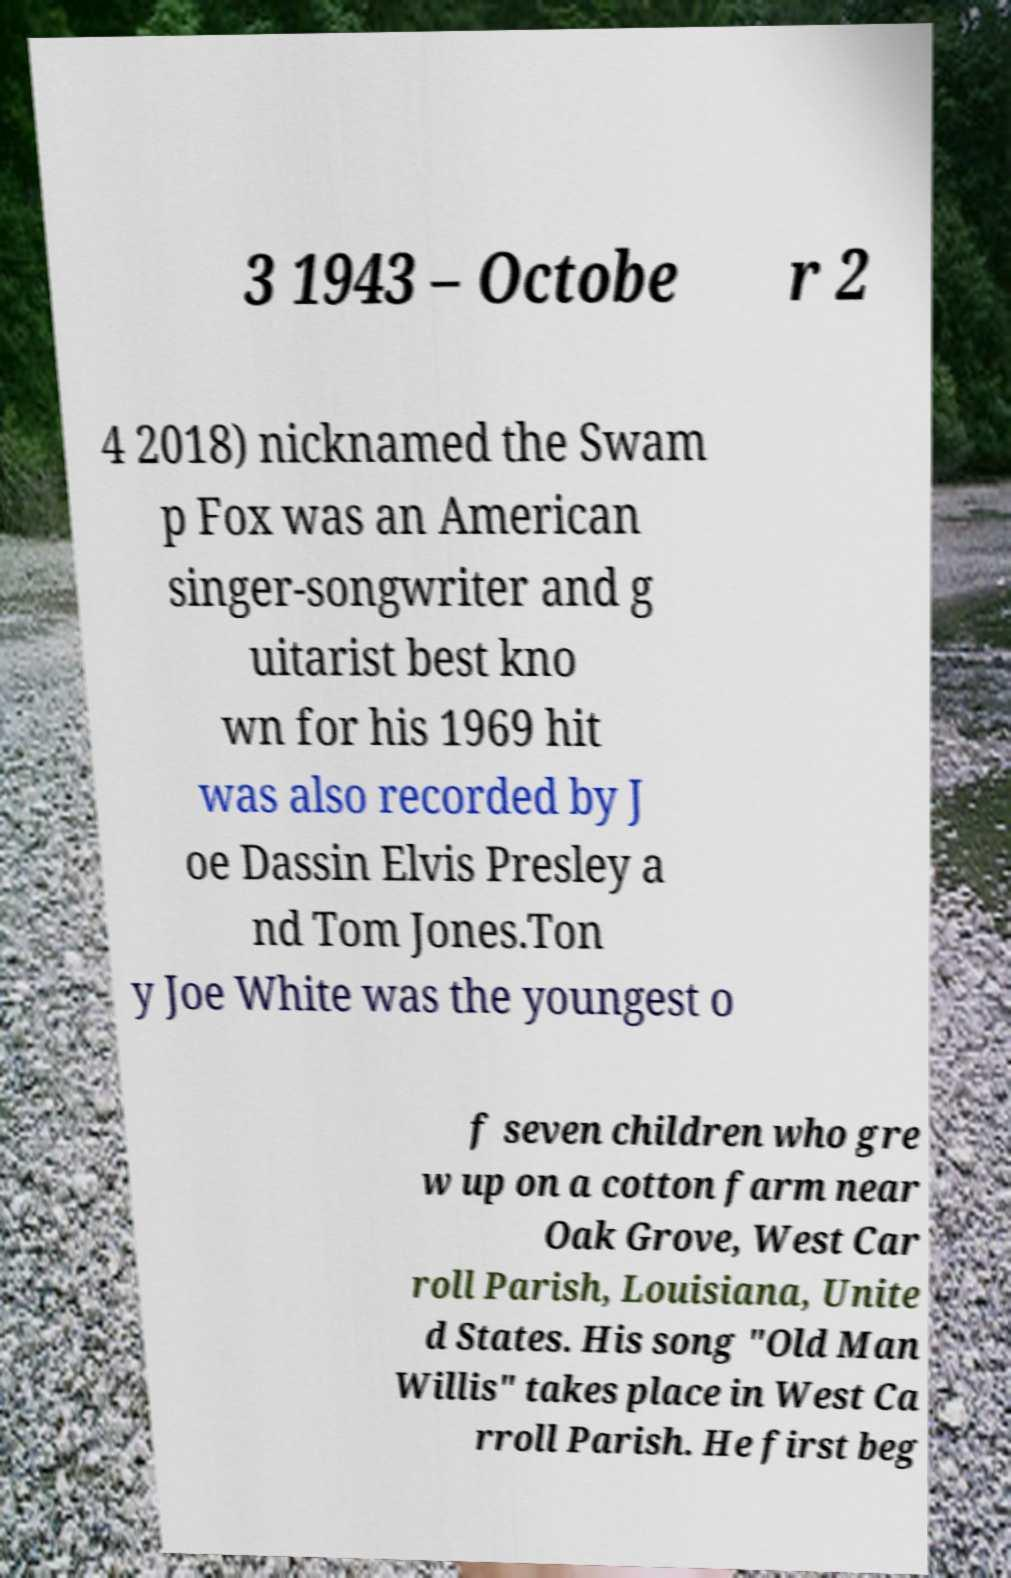I need the written content from this picture converted into text. Can you do that? 3 1943 – Octobe r 2 4 2018) nicknamed the Swam p Fox was an American singer-songwriter and g uitarist best kno wn for his 1969 hit was also recorded by J oe Dassin Elvis Presley a nd Tom Jones.Ton y Joe White was the youngest o f seven children who gre w up on a cotton farm near Oak Grove, West Car roll Parish, Louisiana, Unite d States. His song "Old Man Willis" takes place in West Ca rroll Parish. He first beg 